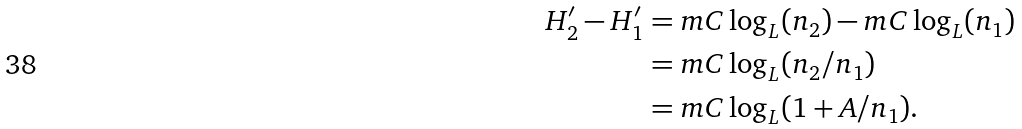<formula> <loc_0><loc_0><loc_500><loc_500>H _ { 2 } ^ { \prime } - H _ { 1 } ^ { \prime } & = m C \log _ { L } ( n _ { 2 } ) - m C \log _ { L } ( n _ { 1 } ) \\ & = m C \log _ { L } ( n _ { 2 } / n _ { 1 } ) \\ & = m C \log _ { L } ( 1 + A / n _ { 1 } ) .</formula> 